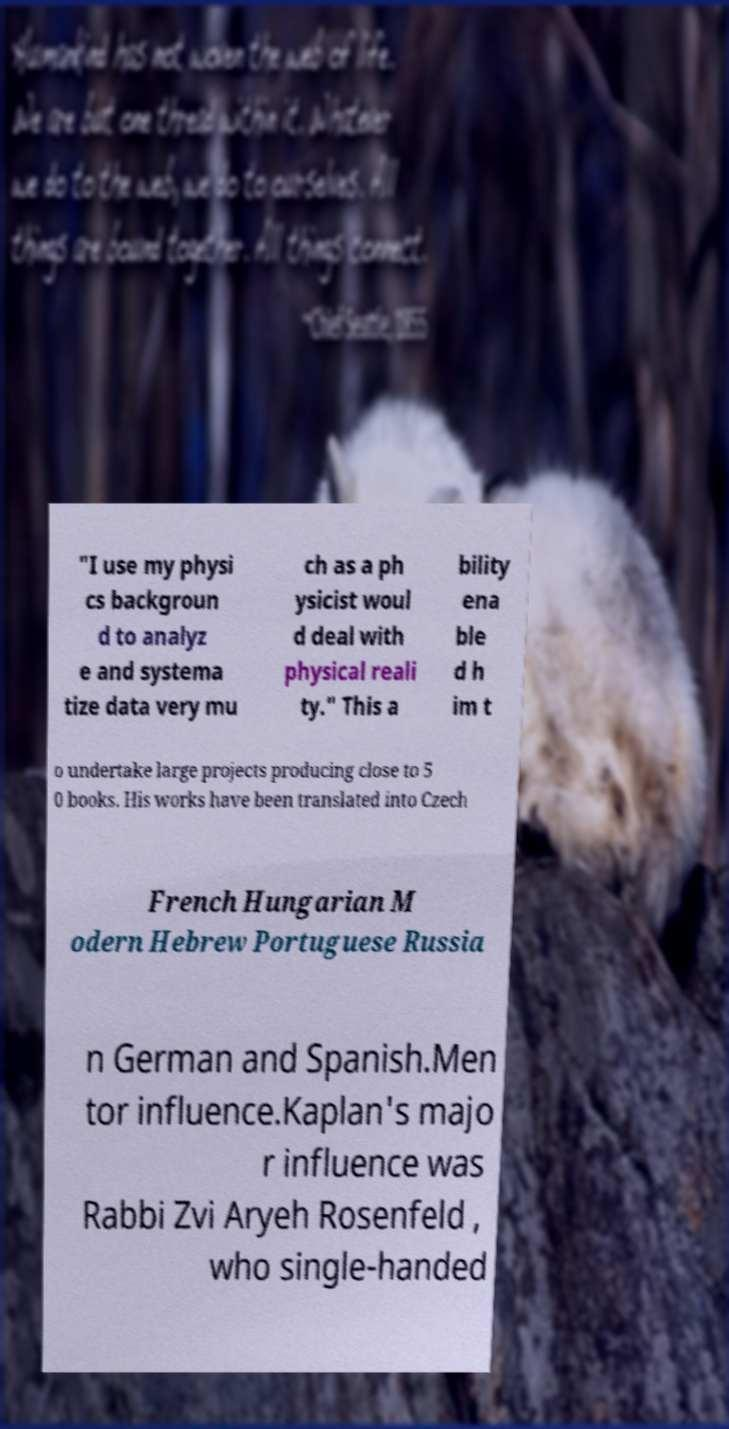Please read and relay the text visible in this image. What does it say? "I use my physi cs backgroun d to analyz e and systema tize data very mu ch as a ph ysicist woul d deal with physical reali ty." This a bility ena ble d h im t o undertake large projects producing close to 5 0 books. His works have been translated into Czech French Hungarian M odern Hebrew Portuguese Russia n German and Spanish.Men tor influence.Kaplan's majo r influence was Rabbi Zvi Aryeh Rosenfeld , who single-handed 